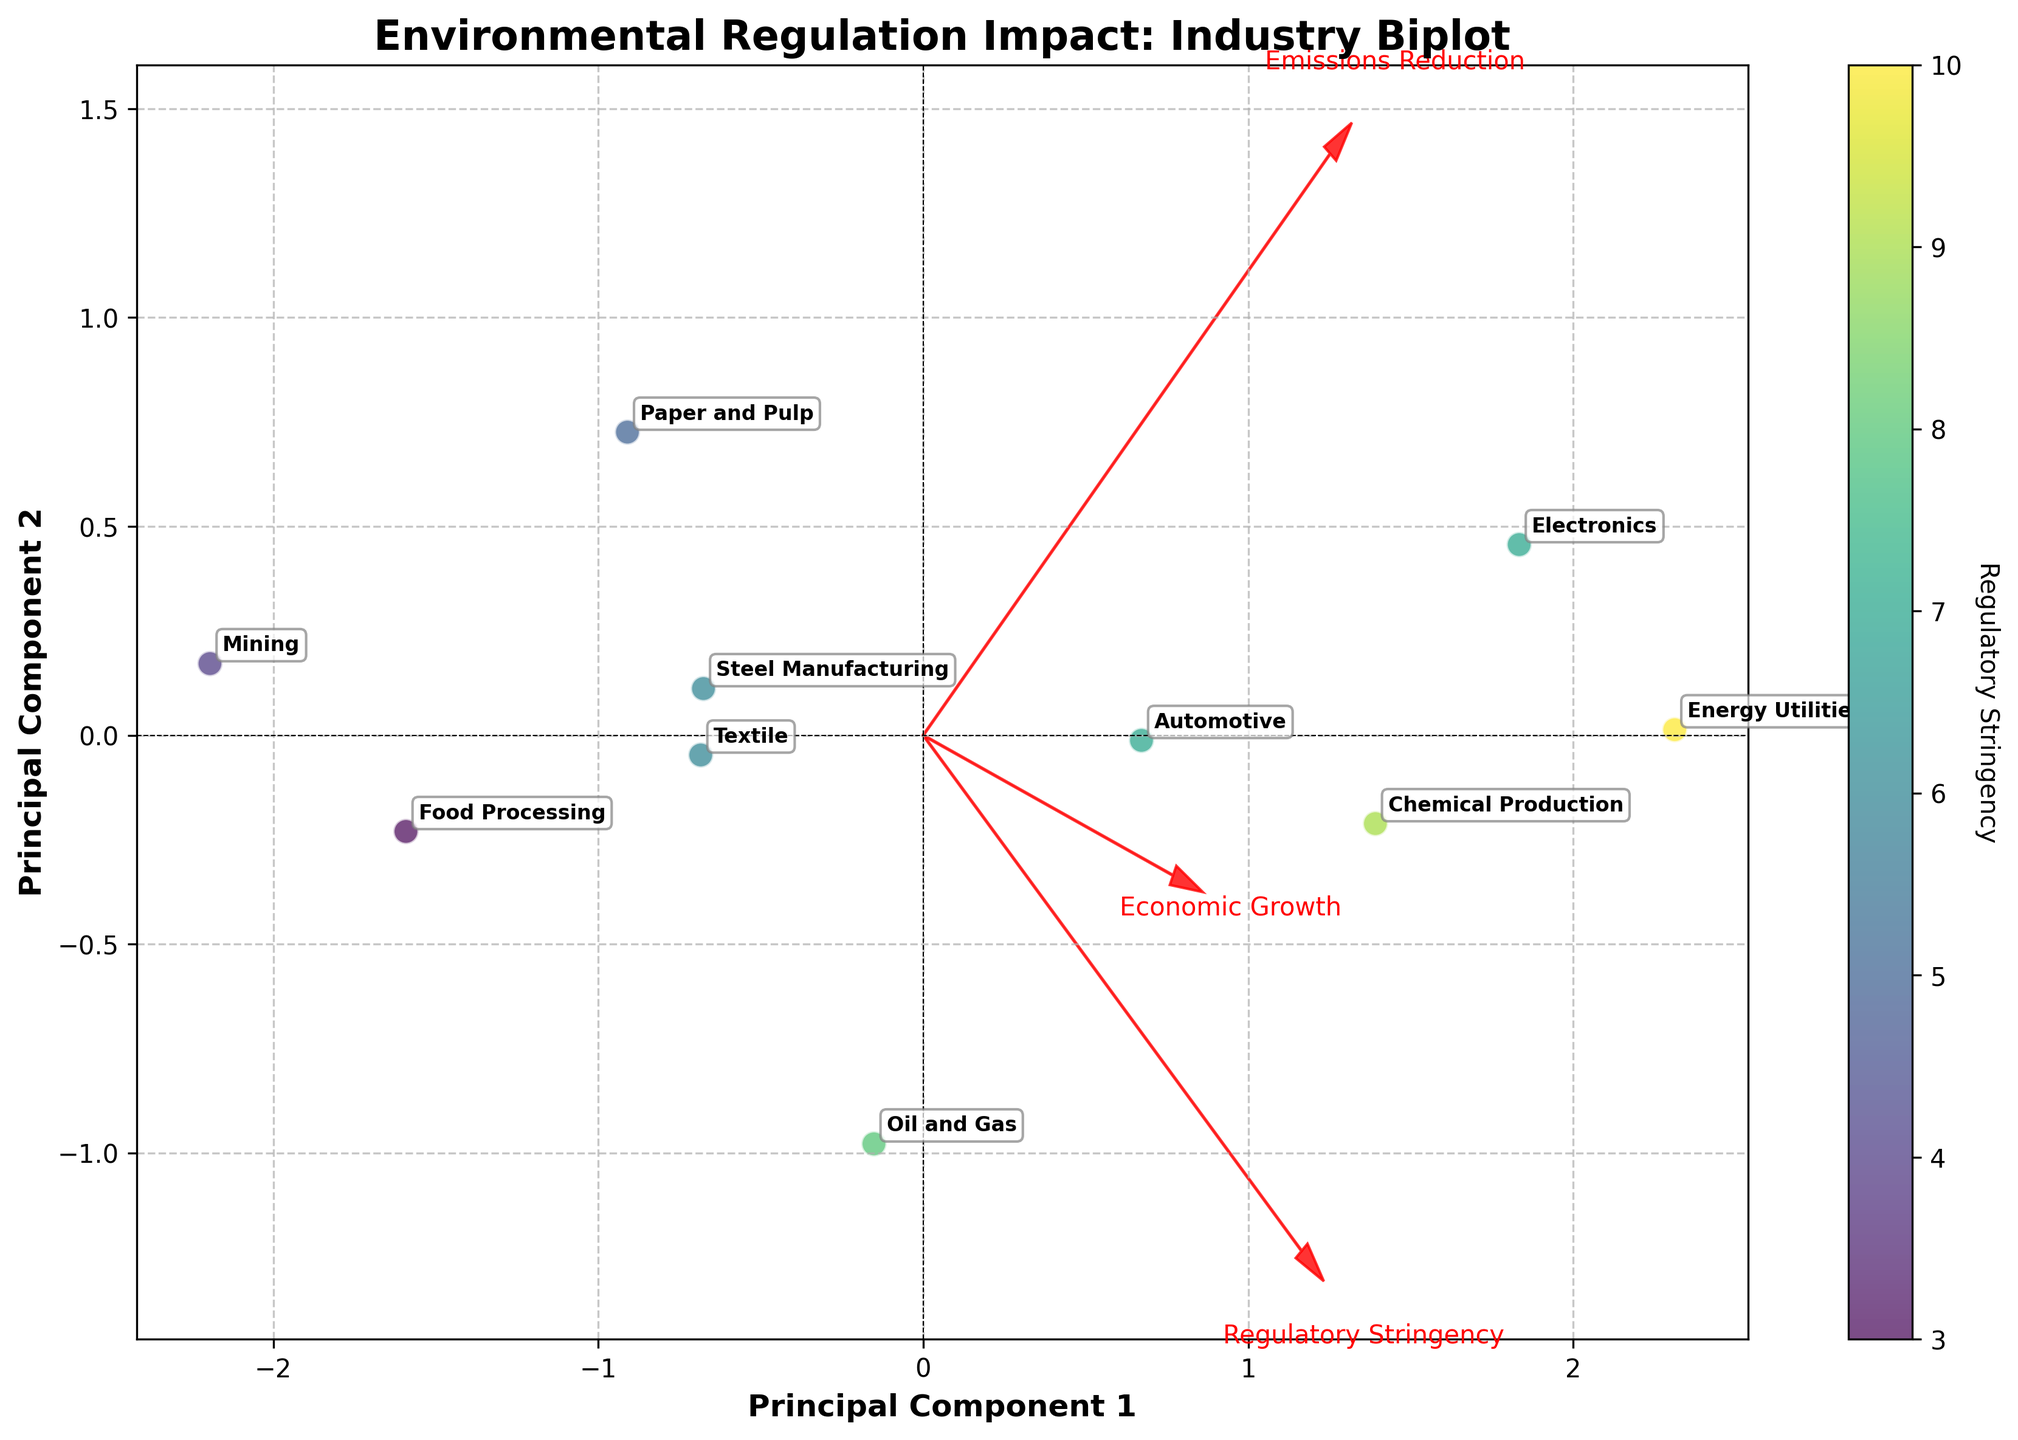What's the title of the plot? The title is prominently displayed at the top of the figure for quick reference. By reading the text there, we can see that the title is "Environmental Regulation Impact: Industry Biplot."
Answer: "Environmental Regulation Impact: Industry Biplot" How many principal components are shown on the axes? The axes are labeled as "Principal Component 1" and "Principal Component 2," indicating that the plot is displaying two principal components.
Answer: Two Which industry is located furthest to the right on the plot? By examining the position of the data points along the x-axis (Principal Component 1), the furthest right point corresponds to the industry labeled "Electronics."
Answer: Electronics Which industry shows the highest regulatory stringency based on the color scale? By interpreting the color gradient legend, which ranges from lighter to darker representing stringency levels from 1 to 10, the point with the darkest color is "Energy Utilities."
Answer: Energy Utilities What relationship can you observe between emissions reduction and regulatory stringency based on the feature vectors? The feature vector for "Emissions Reduction" points in a similar direction to the "Regulatory Stringency" vector, suggesting a positive correlation between higher emissions reduction and stronger regulatory stringency.
Answer: Positive correlation Does any industry exhibit both high economic growth and high emissions reduction? By looking at the upper right quadrant where high values of both principal components would be present, "Electronics" stands out as exhibiting both high economic growth and high emissions reduction.
Answer: Electronics Compare the principal component scores for "Mining" and "Food Processing". Which industry is closer to the center along both principal components? By visually assessing the proximity of the data points to the origin (0,0) of the plot, "Mining" is closer along both the x-axis and y-axis compared to "Food Processing."
Answer: Mining Which feature vector is most closely aligned with Principal Component 1? By examining the angles of the feature vectors with respect to the horizontal axis (Principal Component 1), the "Emissions Reduction" vector is the most closely aligned.
Answer: Emissions Reduction Determine the industry with the lowest economic growth. Observing the positions of the data points relative to the y-axis (Principal Component 2) and cross-referencing the labels, "Mining" is located lowest, indicating the least economic growth.
Answer: Mining 